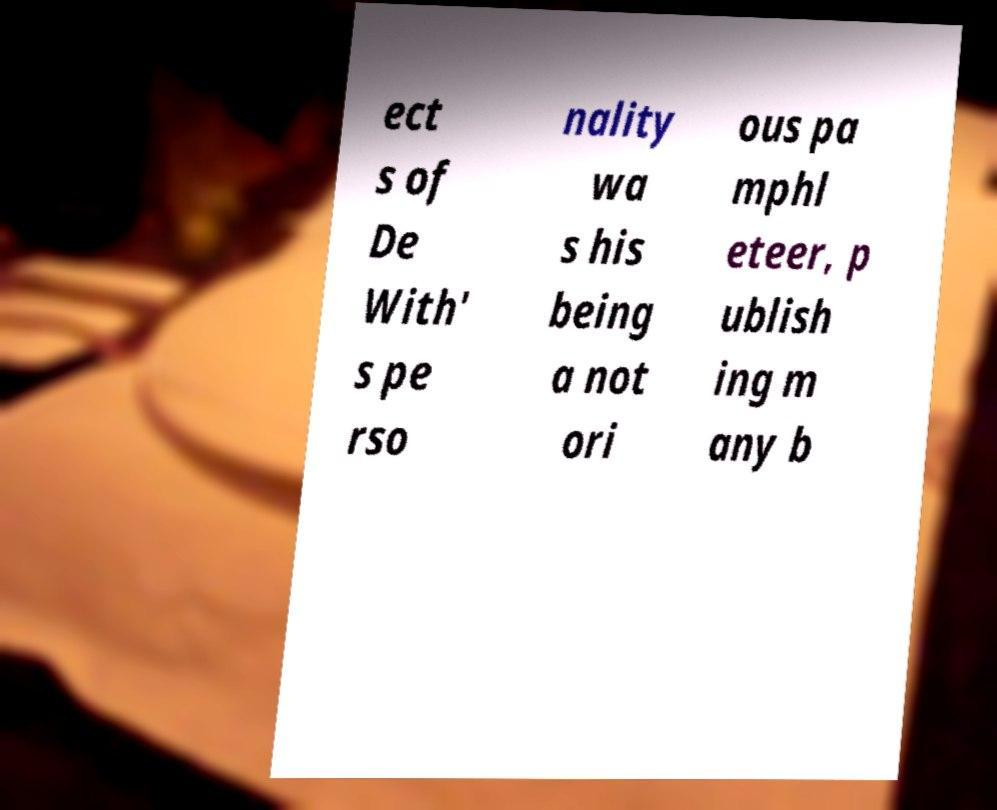Can you accurately transcribe the text from the provided image for me? ect s of De With' s pe rso nality wa s his being a not ori ous pa mphl eteer, p ublish ing m any b 